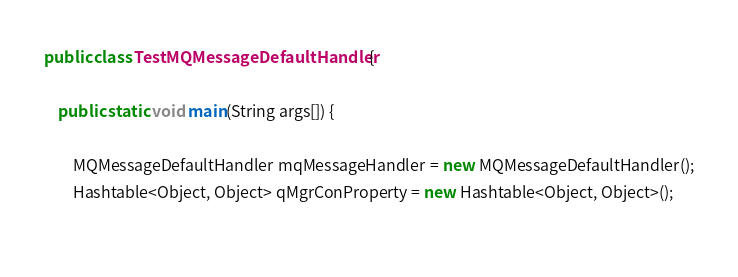<code> <loc_0><loc_0><loc_500><loc_500><_Java_>public class TestMQMessageDefaultHandler {

	public static void main(String args[]) {

		MQMessageDefaultHandler mqMessageHandler = new MQMessageDefaultHandler();
		Hashtable<Object, Object> qMgrConProperty = new Hashtable<Object, Object>();
        </code> 